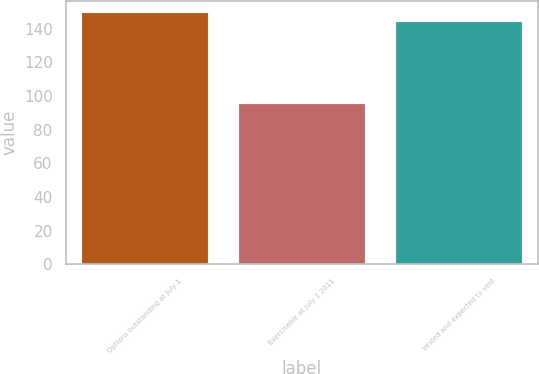Convert chart. <chart><loc_0><loc_0><loc_500><loc_500><bar_chart><fcel>Options outstanding at July 1<fcel>Exercisable at July 1 2011<fcel>Vested and expected to vest<nl><fcel>149<fcel>95<fcel>144<nl></chart> 